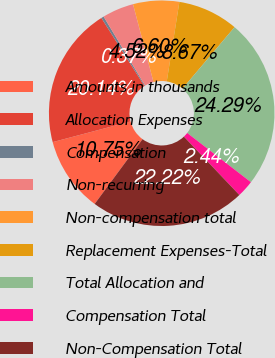Convert chart to OTSL. <chart><loc_0><loc_0><loc_500><loc_500><pie_chart><fcel>Amounts in thousands<fcel>Allocation Expenses<fcel>Compensation<fcel>Non-recurring<fcel>Non-compensation total<fcel>Replacement Expenses-Total<fcel>Total Allocation and<fcel>Compensation Total<fcel>Non-Compensation Total<nl><fcel>10.75%<fcel>20.14%<fcel>0.37%<fcel>4.52%<fcel>6.6%<fcel>8.67%<fcel>24.29%<fcel>2.44%<fcel>22.22%<nl></chart> 